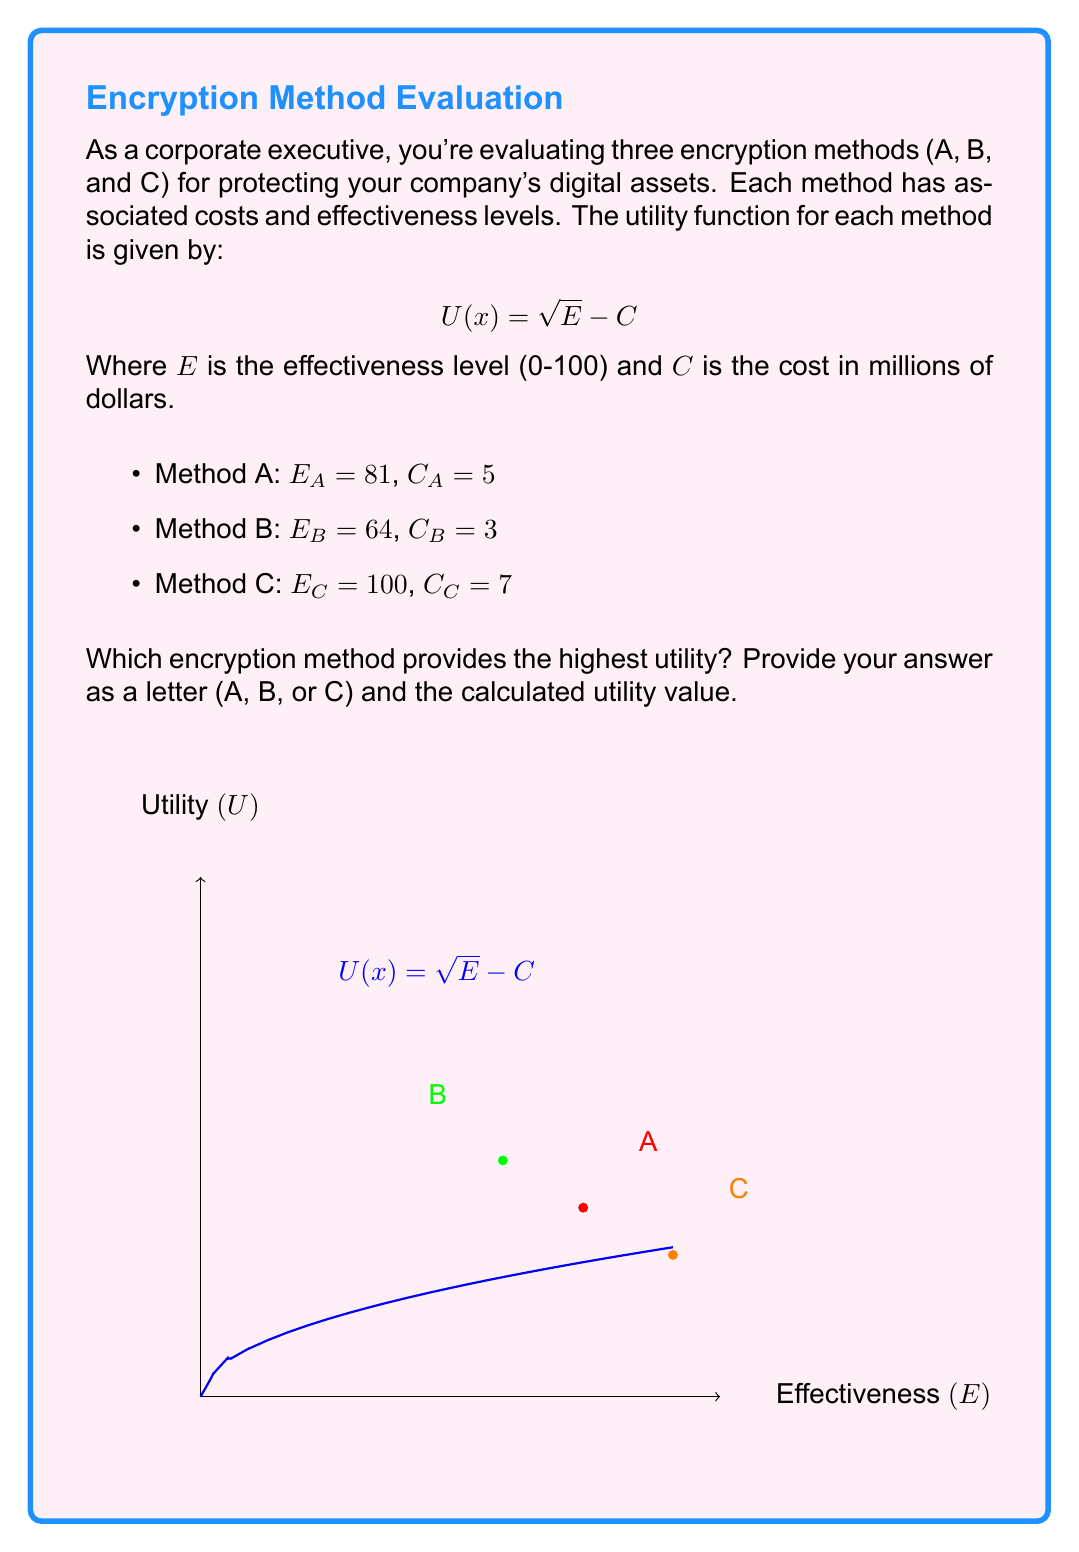What is the answer to this math problem? Let's calculate the utility for each method using the given formula $U(x) = \sqrt{E} - C$:

1. Method A:
   $U_A = \sqrt{E_A} - C_A = \sqrt{81} - 5 = 9 - 5 = 4$

2. Method B:
   $U_B = \sqrt{E_B} - C_B = \sqrt{64} - 3 = 8 - 3 = 5$

3. Method C:
   $U_C = \sqrt{E_C} - C_C = \sqrt{100} - 7 = 10 - 7 = 3$

Comparing the utility values:
$U_B (5) > U_A (4) > U_C (3)$

Therefore, Method B provides the highest utility.
Answer: B, 5 